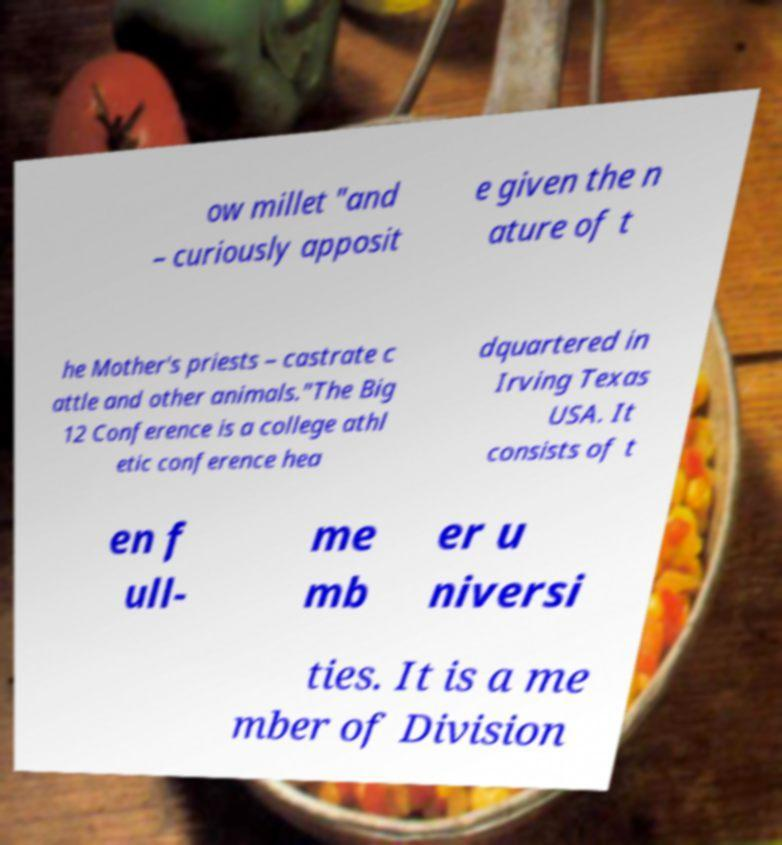Please identify and transcribe the text found in this image. ow millet "and – curiously apposit e given the n ature of t he Mother's priests – castrate c attle and other animals."The Big 12 Conference is a college athl etic conference hea dquartered in Irving Texas USA. It consists of t en f ull- me mb er u niversi ties. It is a me mber of Division 